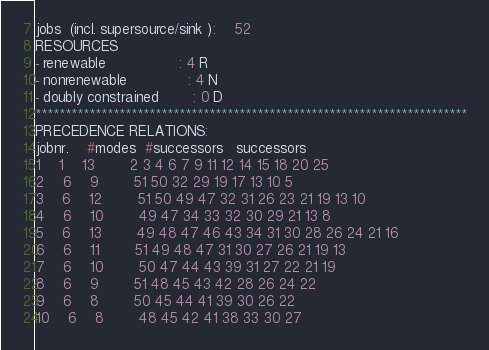<code> <loc_0><loc_0><loc_500><loc_500><_ObjectiveC_>jobs  (incl. supersource/sink ):	52
RESOURCES
- renewable                 : 4 R
- nonrenewable              : 4 N
- doubly constrained        : 0 D
************************************************************************
PRECEDENCE RELATIONS:
jobnr.    #modes  #successors   successors
1	1	13		2 3 4 6 7 9 11 12 14 15 18 20 25 
2	6	9		51 50 32 29 19 17 13 10 5 
3	6	12		51 50 49 47 32 31 26 23 21 19 13 10 
4	6	10		49 47 34 33 32 30 29 21 13 8 
5	6	13		49 48 47 46 43 34 31 30 28 26 24 21 16 
6	6	11		51 49 48 47 31 30 27 26 21 19 13 
7	6	10		50 47 44 43 39 31 27 22 21 19 
8	6	9		51 48 45 43 42 28 26 24 22 
9	6	8		50 45 44 41 39 30 26 22 
10	6	8		48 45 42 41 38 33 30 27 </code> 